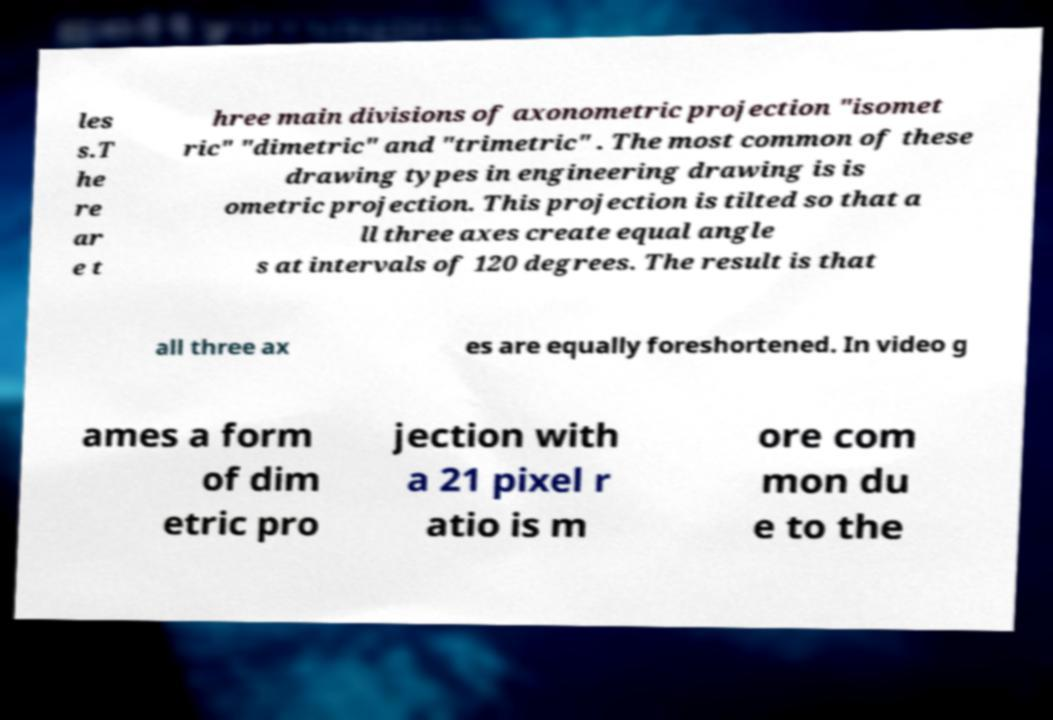What messages or text are displayed in this image? I need them in a readable, typed format. les s.T he re ar e t hree main divisions of axonometric projection "isomet ric" "dimetric" and "trimetric" . The most common of these drawing types in engineering drawing is is ometric projection. This projection is tilted so that a ll three axes create equal angle s at intervals of 120 degrees. The result is that all three ax es are equally foreshortened. In video g ames a form of dim etric pro jection with a 21 pixel r atio is m ore com mon du e to the 